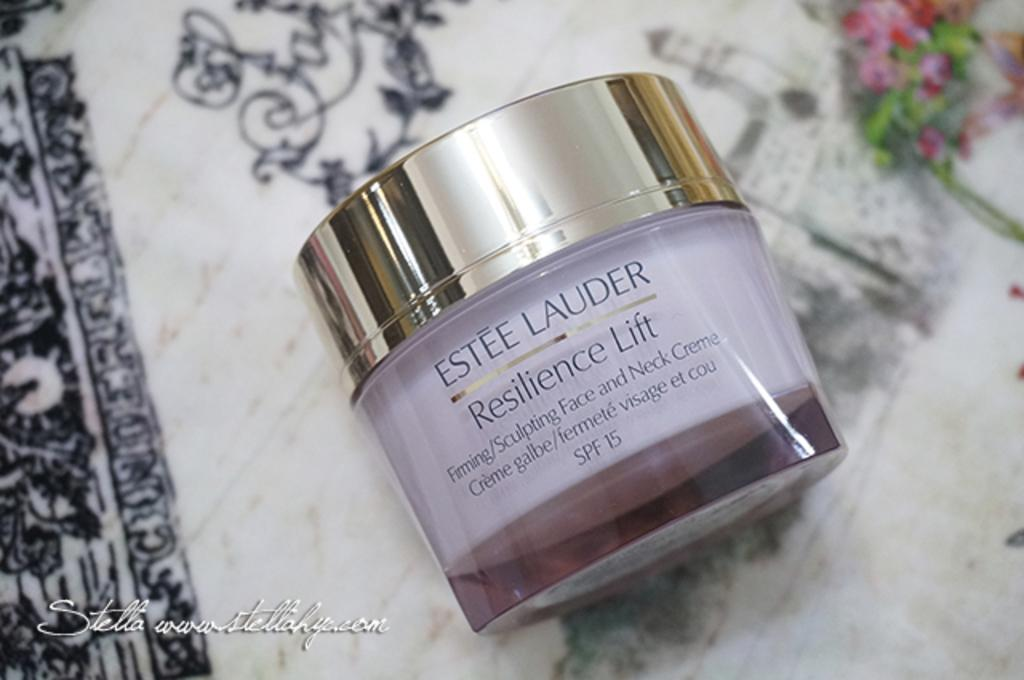<image>
Present a compact description of the photo's key features. A jar of Estee Lauder resilience lift has an SPF of 15. 